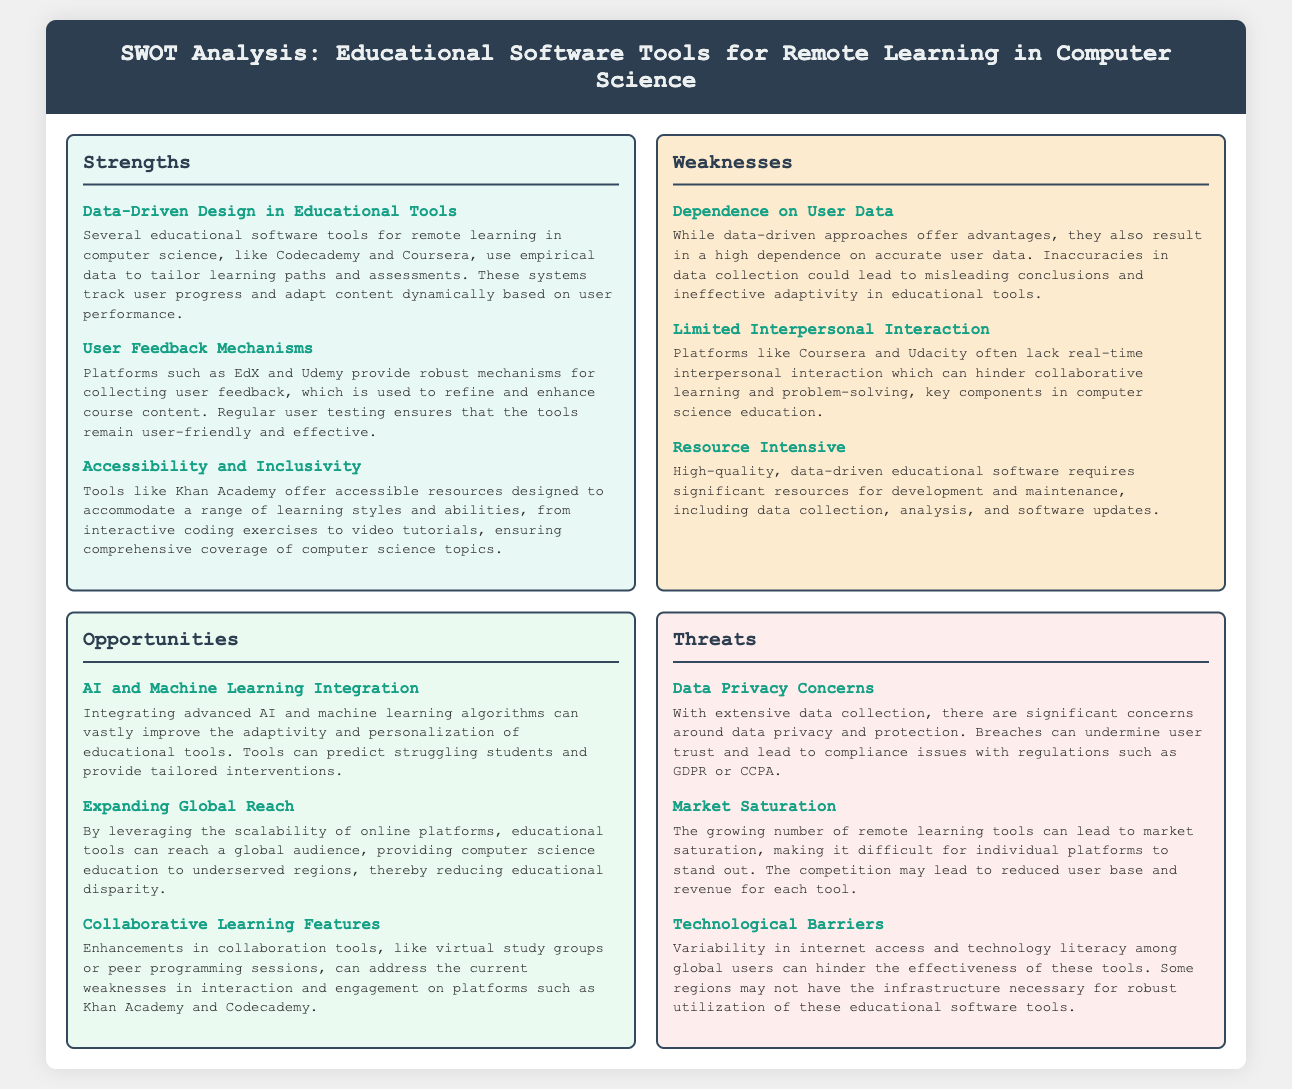What is one strength of educational software tools mentioned? The document lists multiple strengths, one of which is that educational software tools use empirical data to tailor learning paths.
Answer: Data-Driven Design in Educational Tools What is a noted weakness in remote learning platforms? The document identifies several weaknesses, including the lack of real-time interpersonal interaction as a significant concern.
Answer: Limited Interpersonal Interaction What opportunity could enhance educational tools according to the analysis? A potential opportunity mentioned is the integration of AI to improve adaptivity and personalization in educational tools.
Answer: AI and Machine Learning Integration What threat is associated with data privacy in educational tools? The document discusses data privacy concerns as a major threat due to extensive data collection practices.
Answer: Data Privacy Concerns How many strengths are listed in the SWOT analysis? The strengths section contains three distinct points listed in the analysis.
Answer: Three What kind of educational tool improvements does the document suggest? The document suggests enhancements in collaborative learning features to improve engagement among users.
Answer: Collaborative Learning Features Which platform is highlighted for its user feedback mechanisms? The document mentions EdX as a platform that provides robust mechanisms for collecting user feedback.
Answer: EdX What is a consequence of market saturation on educational software tools? The document indicates that market saturation can make it difficult for individual platforms to stand out, leading to reduced user base.
Answer: Reduced user base What does the analysis say about the resource requirements for educational software? The document notes that developing high-quality educational software is resource-intensive, requiring significant investments.
Answer: Resource Intensive 